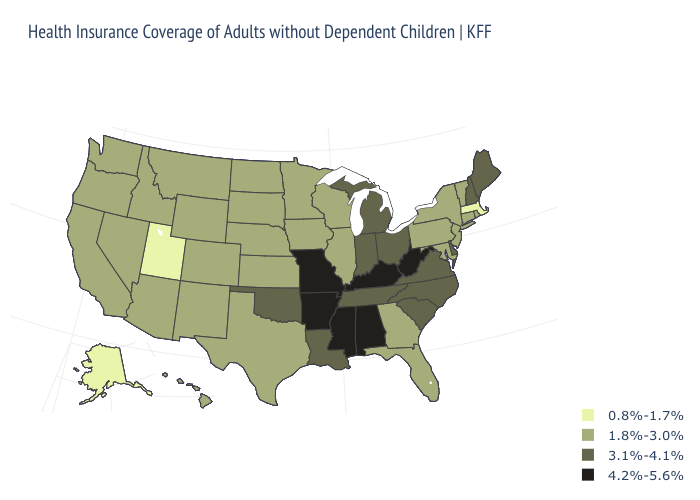Which states have the highest value in the USA?
Write a very short answer. Alabama, Arkansas, Kentucky, Mississippi, Missouri, West Virginia. Is the legend a continuous bar?
Write a very short answer. No. Does North Dakota have the highest value in the MidWest?
Keep it brief. No. What is the value of North Carolina?
Give a very brief answer. 3.1%-4.1%. What is the lowest value in states that border New York?
Be succinct. 0.8%-1.7%. What is the lowest value in the West?
Concise answer only. 0.8%-1.7%. What is the value of New Jersey?
Answer briefly. 1.8%-3.0%. What is the value of Alabama?
Give a very brief answer. 4.2%-5.6%. What is the value of Kansas?
Write a very short answer. 1.8%-3.0%. Name the states that have a value in the range 0.8%-1.7%?
Give a very brief answer. Alaska, Massachusetts, Utah. How many symbols are there in the legend?
Concise answer only. 4. What is the value of Pennsylvania?
Write a very short answer. 1.8%-3.0%. Does Mississippi have the same value as West Virginia?
Be succinct. Yes. How many symbols are there in the legend?
Keep it brief. 4. 